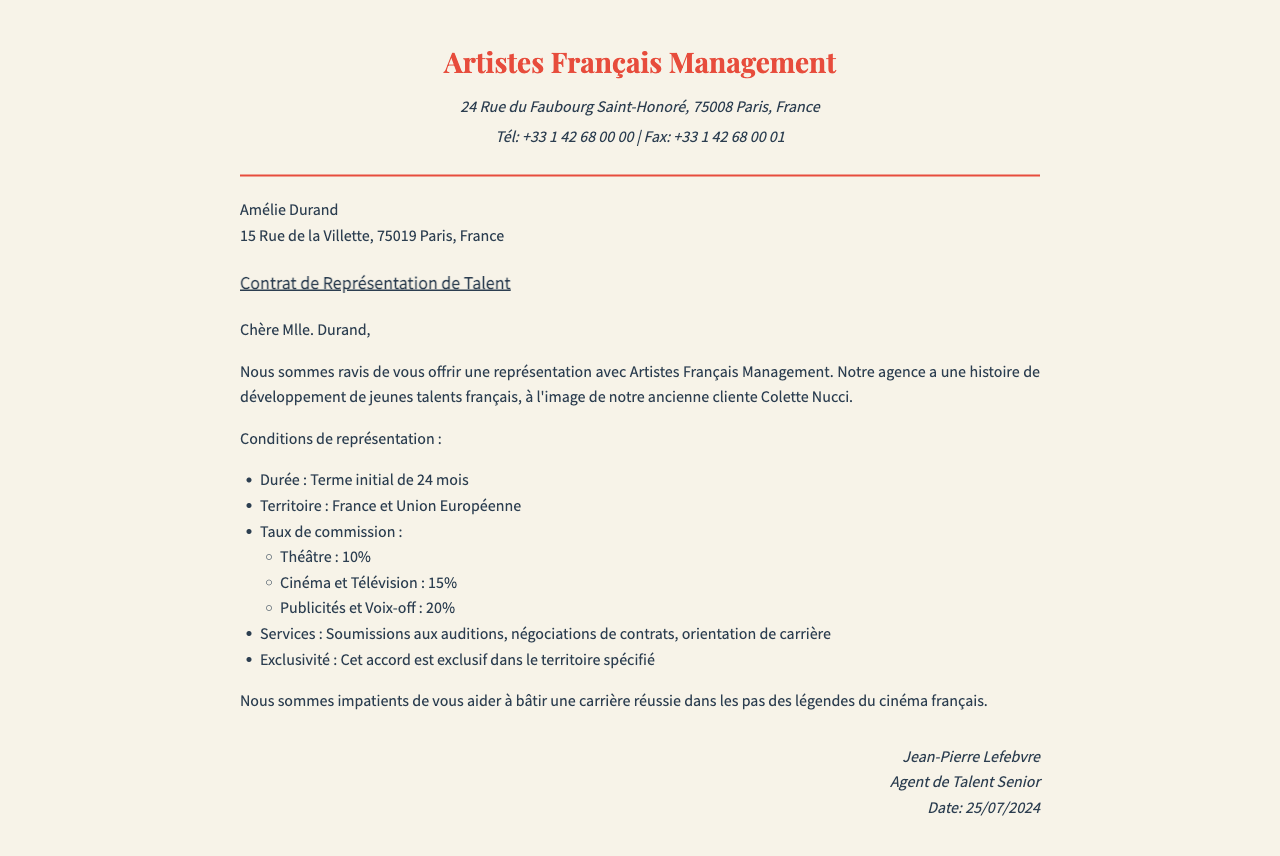Quelle est la durée du contrat ? La durée du contrat est spécifiée dans le document comme un terme initial de 24 mois.
Answer: 24 mois Quel est le taux de commission pour le cinéma et la télévision ? Le document indique que le taux de commission pour le cinéma et la télévision est de 15%.
Answer: 15% Quelles sont les services offerts par l'agence ? Les services mentionnés dans le document incluent soumissions aux auditions, négociations de contrats, et orientation de carrière.
Answer: Soumissions aux auditions, négociations de contrats, orientation de carrière Quel est le nom de l'agent de talent senior ? Le nom de l'agent de talent senior est mentionné à la fin du document.
Answer: Jean-Pierre Lefebvre Quel territoire est couvert par cet accord ? Le document précise que le territoire couvert par cet accord est la France et l'Union Européenne.
Answer: France et Union Européenne Quel est le taux de commission pour les publicités et voix-off ? Le taux de commission pour les publicités et voix-off est clairement indiqué comme étant de 20%.
Answer: 20% Quel est le but principal de cet accord de représentation ? L'objectif principal mentionné dans le document est d'aider à bâtir une carrière réussie.
Answer: Bâtir une carrière réussie Est-ce que cet accord est exclusif ? Le document indique que cet accord est exclusif dans le territoire spécifié.
Answer: Oui, exclusif 